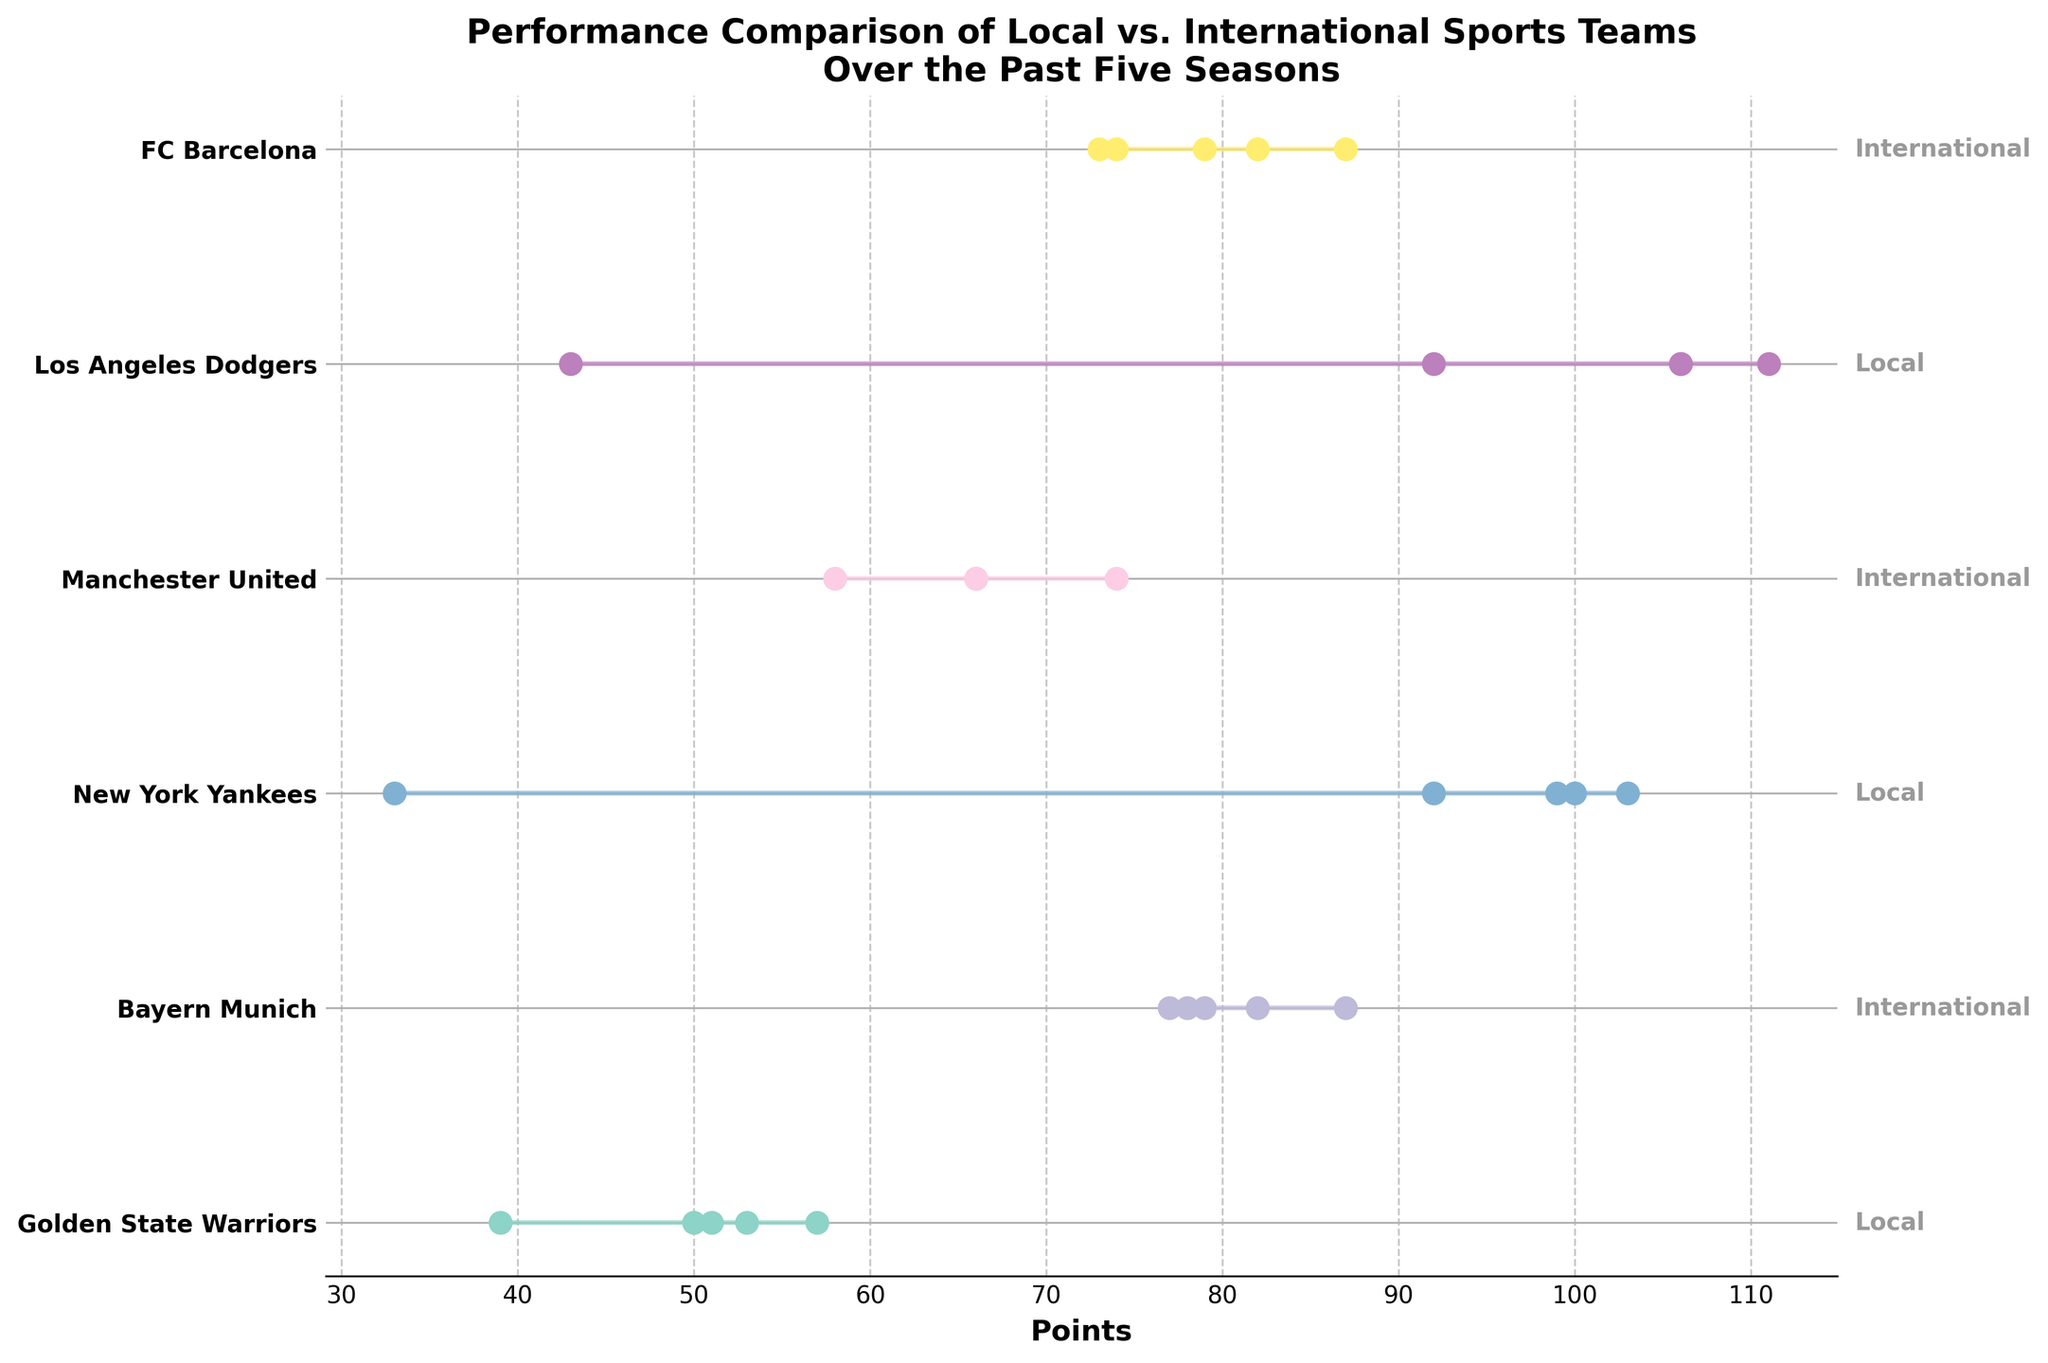What is the title of the plot? The title of the plot is typically at the top of the figure. It provides an overview of what the plot represents. Here, the title indicates a performance comparison of local vs. international sports teams over the past five seasons.
Answer: "Performance Comparison of Local vs. International Sports Teams Over the Past Five Seasons" How many teams are compared in the plot? Count the number of unique y-tick labels on the vertical axis of the plot. Each label represents a different team.
Answer: 6 Which team has the largest range in points over the five seasons? Observe the length of the lines representing the range of points for each team. The team with the longest line has the largest range.
Answer: Los Angeles Dodgers What is the maximum point score for Bayern Munich? Find the line and data points for Bayern Munich. Identify the highest data point on the horizontal axis associated with Bayern Munich.
Answer: 87 How does the performance of Golden State Warriors in 2021 compare to their performance in 2020? Locate the data points for the Golden State Warriors for the years 2021 and 2020. Compare their positions on the horizontal axis to determine which is higher.
Answer: 2021 performance is higher Which team's performance remained constant for the first three seasons? Look for a team whose data points are at the same position on the horizontal axis for the first three years. This indicates no change in performance.
Answer: Manchester United Calculate the average points scored by New York Yankees over the five seasons. Add up the points scored by New York Yankees for each year (100 + 103 + 33 + 92 + 99) and then divide by the number of seasons (5).
Answer: 85.4 Who had a better performance in 2019, FC Barcelona or Bayern Munich? Compare the positions of the data points for FC Barcelona and Bayern Munich in 2019. The one further to the right on the horizontal axis has a better performance.
Answer: Bayern Munich What is the difference in points between the highest and lowest seasons for Manchester United? Identify the highest and lowest data points for Manchester United. Subtract the lowest from the highest to find the difference.
Answer: 16 points (74 - 58) Which team has the most consistent performance across the five seasons? Determine which team has the shortest line, indicating the smallest range in points between their highest and lowest seasons.
Answer: Manchester United 